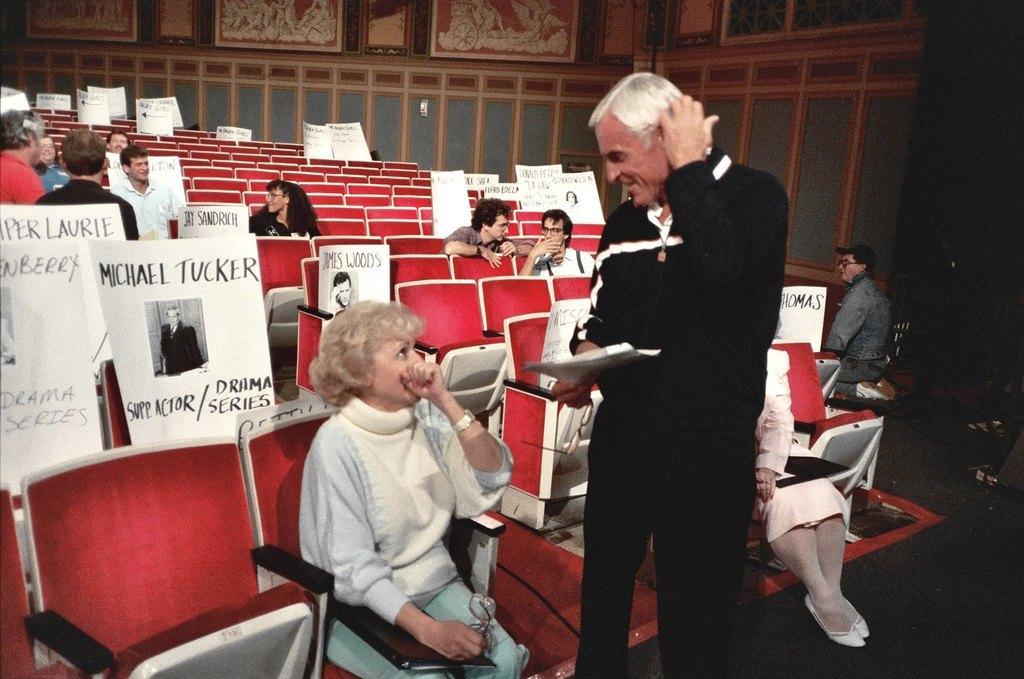Describe this image in one or two sentences. In this picture we can see a man wearing black dress and standing in the front and talking with the woman sitting on the red chair. Behind there are some girls and boys sitting on the chairs with white paper boards. Behind there is a wooden paneling wall and art frames. 